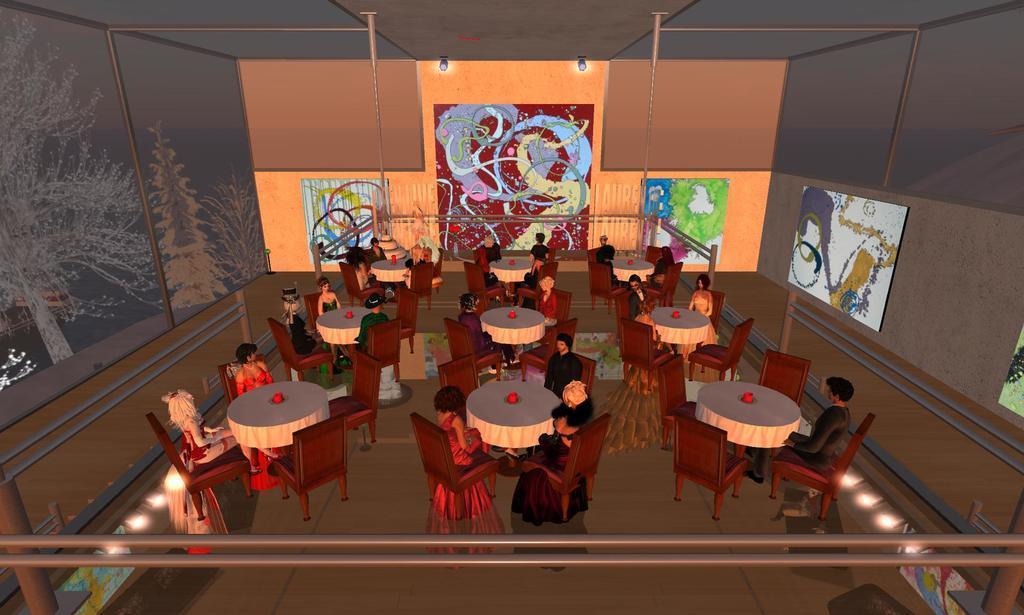How would you summarize this image in a sentence or two? Animated picture. Painted boards are on the walls. Here we can see focusing lights, people, chairs and tables. On these tables there are cloths. Painting is on the wall.  